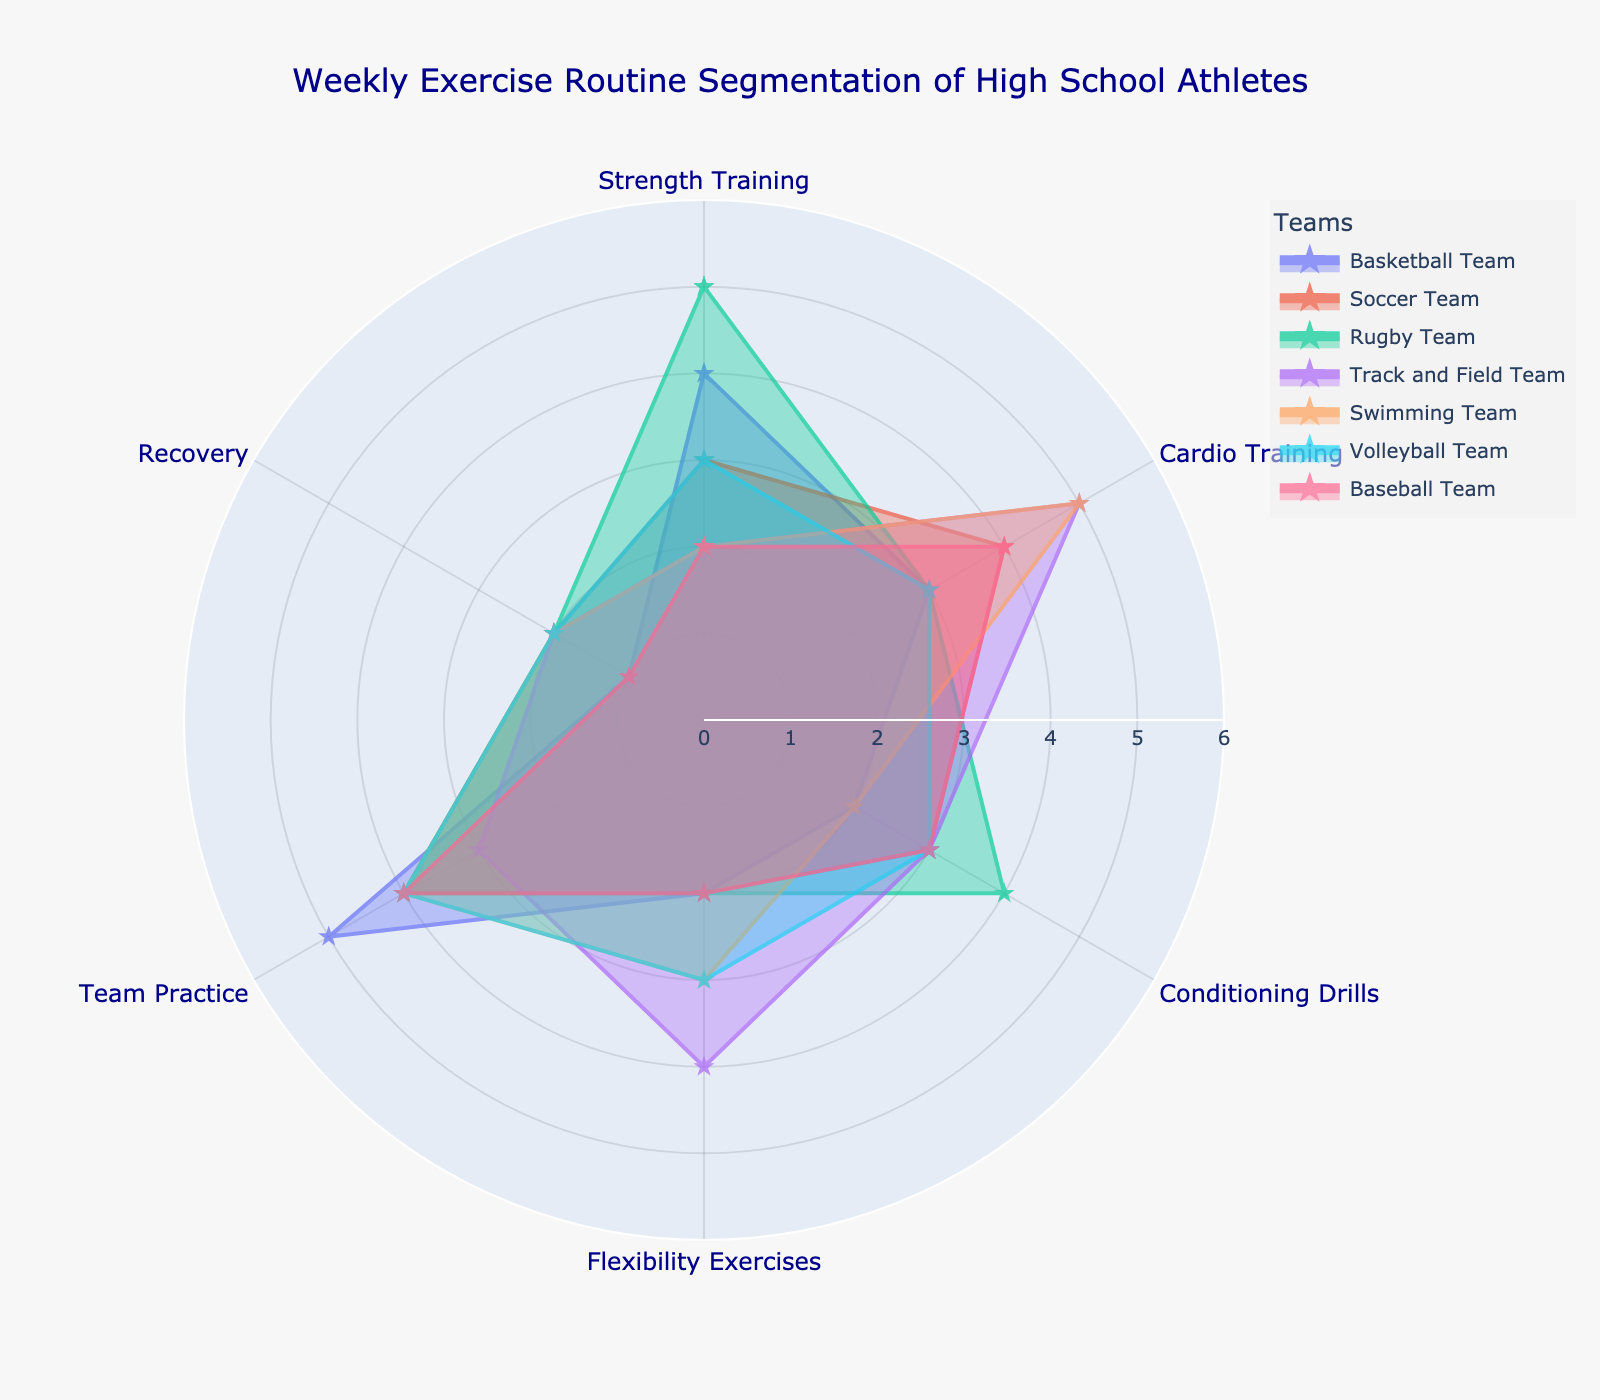What is the title of the figure? The title is located at the top of the figure, generally displayed in a larger font size compared to other text elements and contains a brief description of the content within the plot.
Answer: Weekly Exercise Routine Segmentation of High School Athletes Which team has the highest value for Strength Training? To determine the highest value for Strength Training, observe the length of the segments labeled "Strength Training" across all teams. The longer the segment, the higher the value.
Answer: Rugby Team How many teams have a Recovery value of 2? Count the number of teams where the Recovery section on the polar chart reaches the value of 2 on the radial axis.
Answer: Five teams Which training category does the Soccer Team allocate the most time to? Look at the areas plotted for the Soccer Team and identify the training category with the longest segment, which indicates the highest value.
Answer: Cardio Training What is the average value of Flexibility Exercises across all teams? Sum the Flexibility Exercises values for all the teams and then divide by the number of teams: (2+2+2+4+3+3+2)/7 = 18/7 ≈ 2.57.
Answer: 2.57 Which two teams have equal values for Team Practice? Compare the Team Practice values for each team to find any matches. The teams with equal segments for Team Practice have the same value.
Answer: Soccer Team and Rugby Team Which team has the most evenly distributed exercise routine across all categories? Determine which team's segments in the polar chart are closest in length, indicating similar values across all exercise categories.
Answer: Volleyball Team Which team spends less time on Conditioning Drills compared to Swimming Team? Compare the Conditioning Drills value of Swimming Team with other teams to find which ones have a lower value.
Answer: Basketball Team and Swimming Team How much greater is the Strength Training value for Rugby Team compared to Swimming Team? Subtract the Strength Training value of Swimming Team from Rugby Team's value: 5 (Rugby) - 2 (Swimming) = 3.
Answer: 3 Which category is least emphasized by the Baseball Team? Identify the shortest segment for the Baseball Team, which indicates the lowest value among the training categories.
Answer: Recovery 